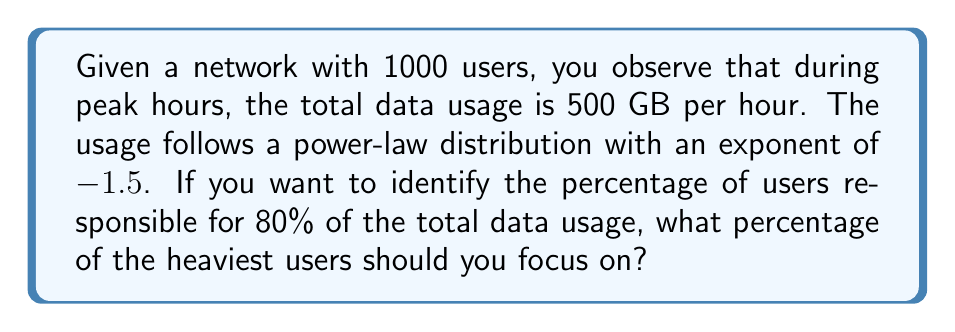Solve this math problem. Let's approach this step-by-step:

1) The power-law distribution is given by:
   $$P(x) \propto x^{-\alpha}$$
   where $\alpha = 1.5$ in this case.

2) For a power-law distribution, the cumulative distribution function (CDF) is:
   $$F(x) = 1 - (\frac{x}{x_{min}})^{-\alpha+1}$$

3) We want to find $x$ such that $F(x) = 0.2$ (as we're looking for the top users responsible for 80% of usage)

4) Substituting into the CDF equation:
   $$0.2 = 1 - (\frac{x}{x_{min}})^{-1.5+1} = 1 - (\frac{x}{x_{min}})^{-0.5}$$

5) Solving for $x$:
   $$(\frac{x}{x_{min}})^{-0.5} = 0.8$$
   $$\frac{x}{x_{min}} = 0.8^{-2} = 1.5625$$

6) This means that the top 1/1.5625 = 0.64 or 64% of users are responsible for 80% of the data usage.

7) Therefore, we need to focus on 100% - 64% = 36% of the heaviest users.
Answer: 36% 